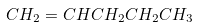Convert formula to latex. <formula><loc_0><loc_0><loc_500><loc_500>C H _ { 2 } = C H C H _ { 2 } C H _ { 2 } C H _ { 3 }</formula> 